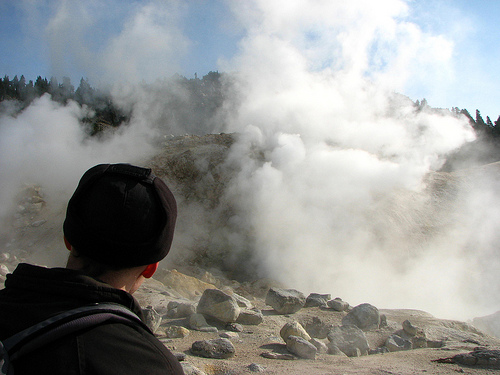<image>
Is there a rock under the sky? Yes. The rock is positioned underneath the sky, with the sky above it in the vertical space. 